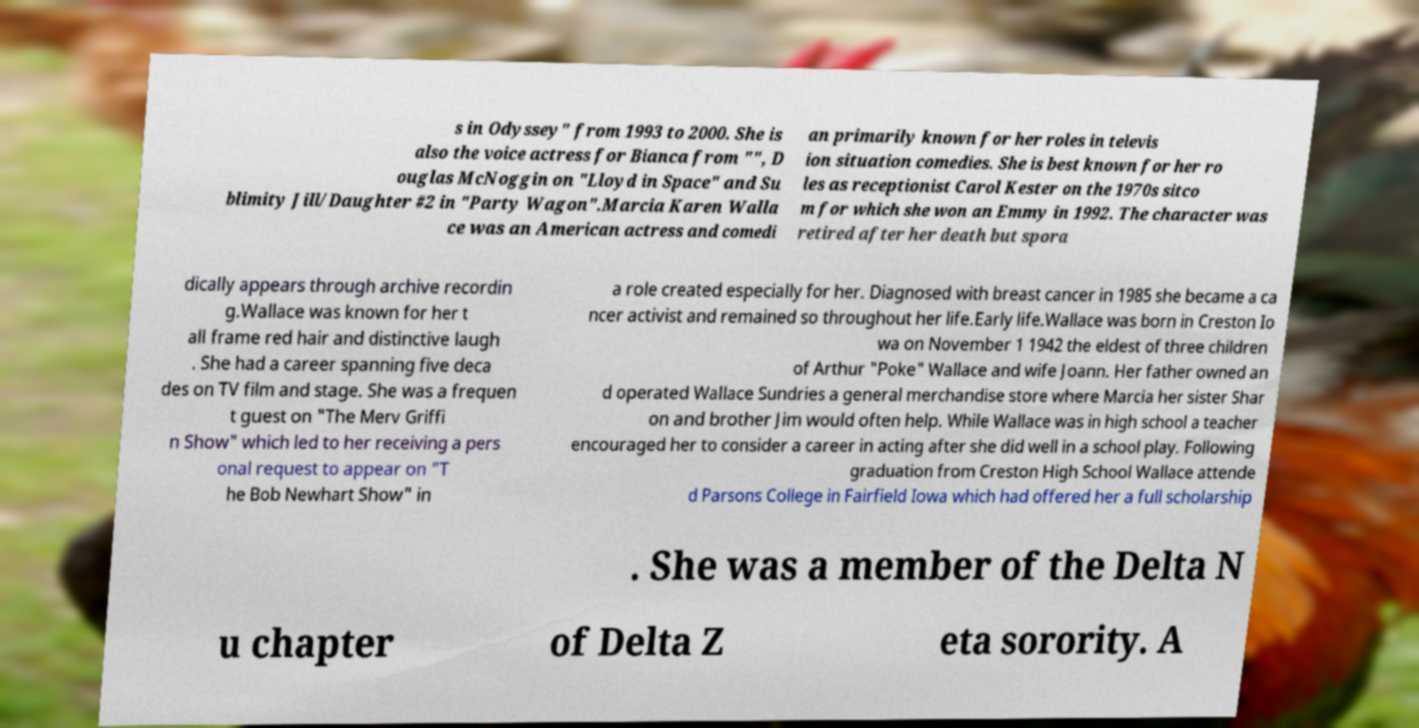Could you assist in decoding the text presented in this image and type it out clearly? s in Odyssey" from 1993 to 2000. She is also the voice actress for Bianca from "", D ouglas McNoggin on "Lloyd in Space" and Su blimity Jill/Daughter #2 in "Party Wagon".Marcia Karen Walla ce was an American actress and comedi an primarily known for her roles in televis ion situation comedies. She is best known for her ro les as receptionist Carol Kester on the 1970s sitco m for which she won an Emmy in 1992. The character was retired after her death but spora dically appears through archive recordin g.Wallace was known for her t all frame red hair and distinctive laugh . She had a career spanning five deca des on TV film and stage. She was a frequen t guest on "The Merv Griffi n Show" which led to her receiving a pers onal request to appear on "T he Bob Newhart Show" in a role created especially for her. Diagnosed with breast cancer in 1985 she became a ca ncer activist and remained so throughout her life.Early life.Wallace was born in Creston Io wa on November 1 1942 the eldest of three children of Arthur "Poke" Wallace and wife Joann. Her father owned an d operated Wallace Sundries a general merchandise store where Marcia her sister Shar on and brother Jim would often help. While Wallace was in high school a teacher encouraged her to consider a career in acting after she did well in a school play. Following graduation from Creston High School Wallace attende d Parsons College in Fairfield Iowa which had offered her a full scholarship . She was a member of the Delta N u chapter of Delta Z eta sorority. A 